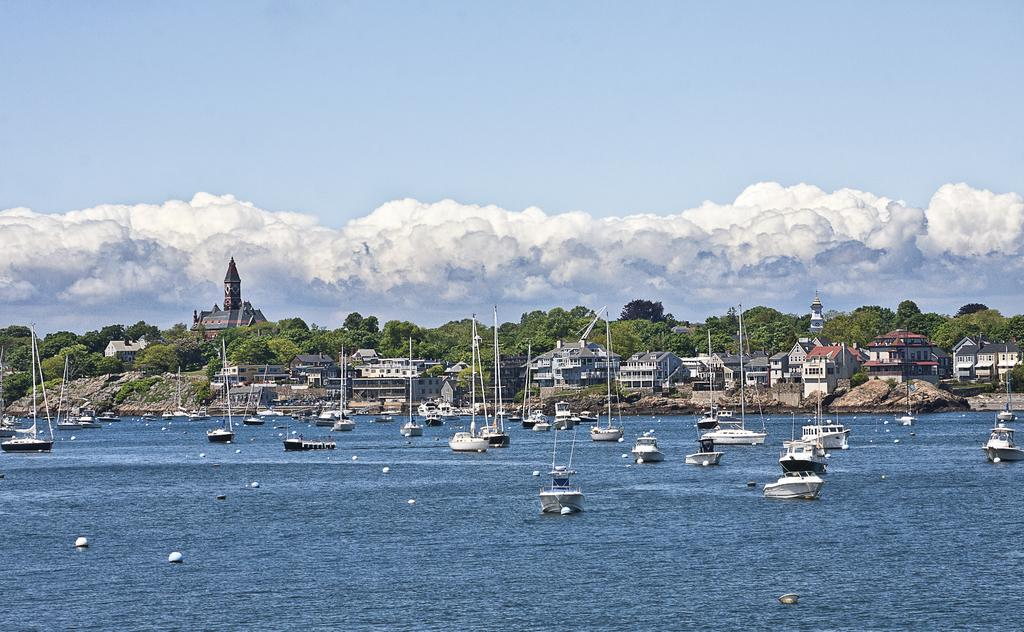What is in the water in the image? There are boats in the water. What can be seen in the background of the image? There are buildings, trees, and the sky visible in the background. What is the condition of the sky in the image? Clouds are present in the sky. Can you tell me how many basketballs are floating in the water? There are no basketballs present in the image; it features boats in the water. How can someone join the boats in the water? The image does not show any way to join the boats, nor does it suggest that joining the boats is possible or necessary. 